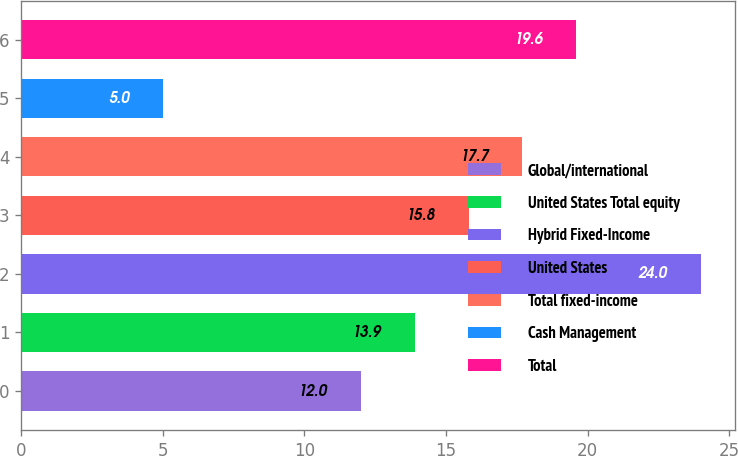<chart> <loc_0><loc_0><loc_500><loc_500><bar_chart><fcel>Global/international<fcel>United States Total equity<fcel>Hybrid Fixed-Income<fcel>United States<fcel>Total fixed-income<fcel>Cash Management<fcel>Total<nl><fcel>12<fcel>13.9<fcel>24<fcel>15.8<fcel>17.7<fcel>5<fcel>19.6<nl></chart> 